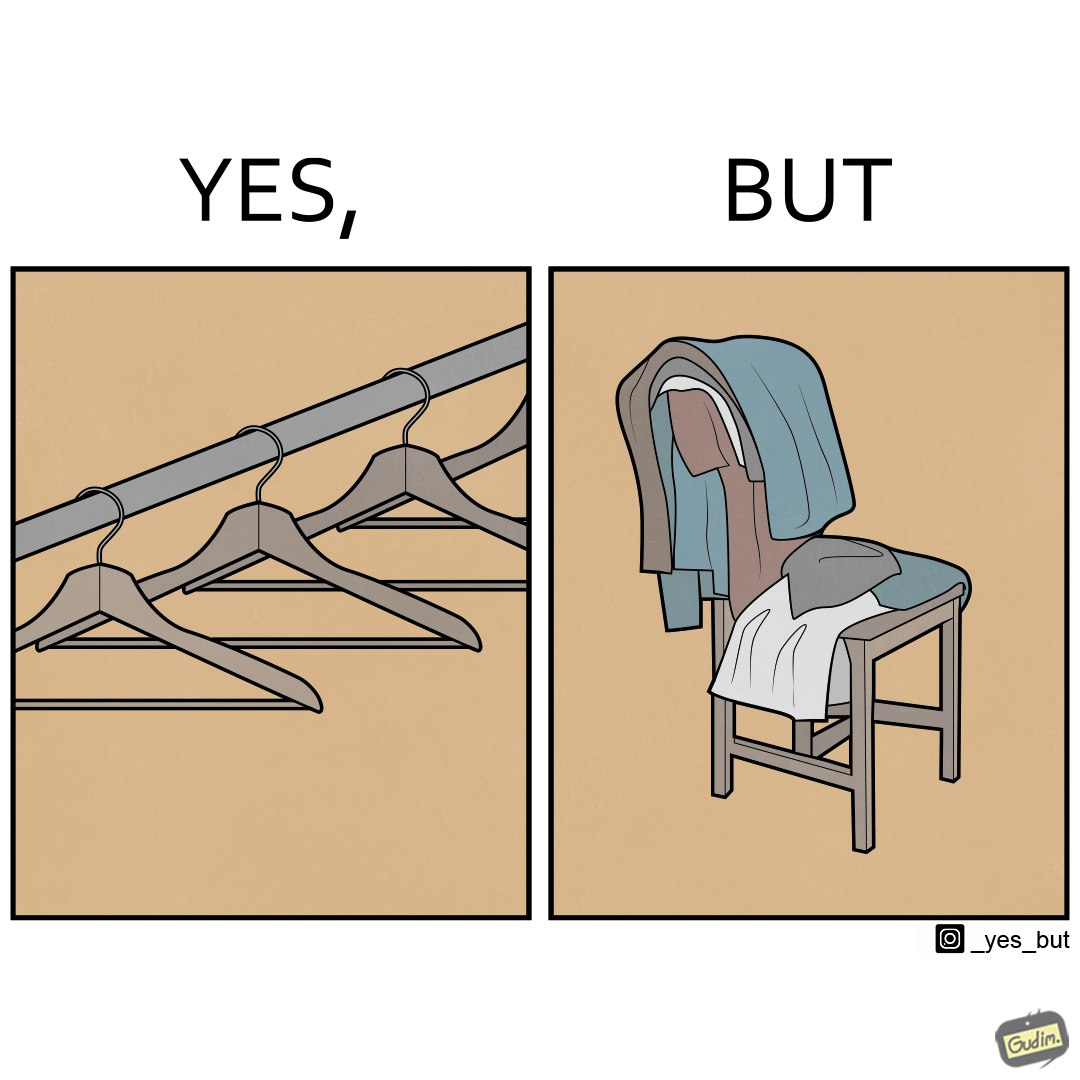What do you see in each half of this image? In the left part of the image: a set of hangars In the right part of the image: a chair with a pile of clothes 